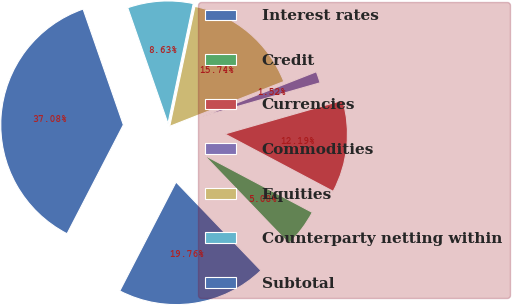Convert chart to OTSL. <chart><loc_0><loc_0><loc_500><loc_500><pie_chart><fcel>Interest rates<fcel>Credit<fcel>Currencies<fcel>Commodities<fcel>Equities<fcel>Counterparty netting within<fcel>Subtotal<nl><fcel>19.76%<fcel>5.08%<fcel>12.19%<fcel>1.52%<fcel>15.74%<fcel>8.63%<fcel>37.08%<nl></chart> 